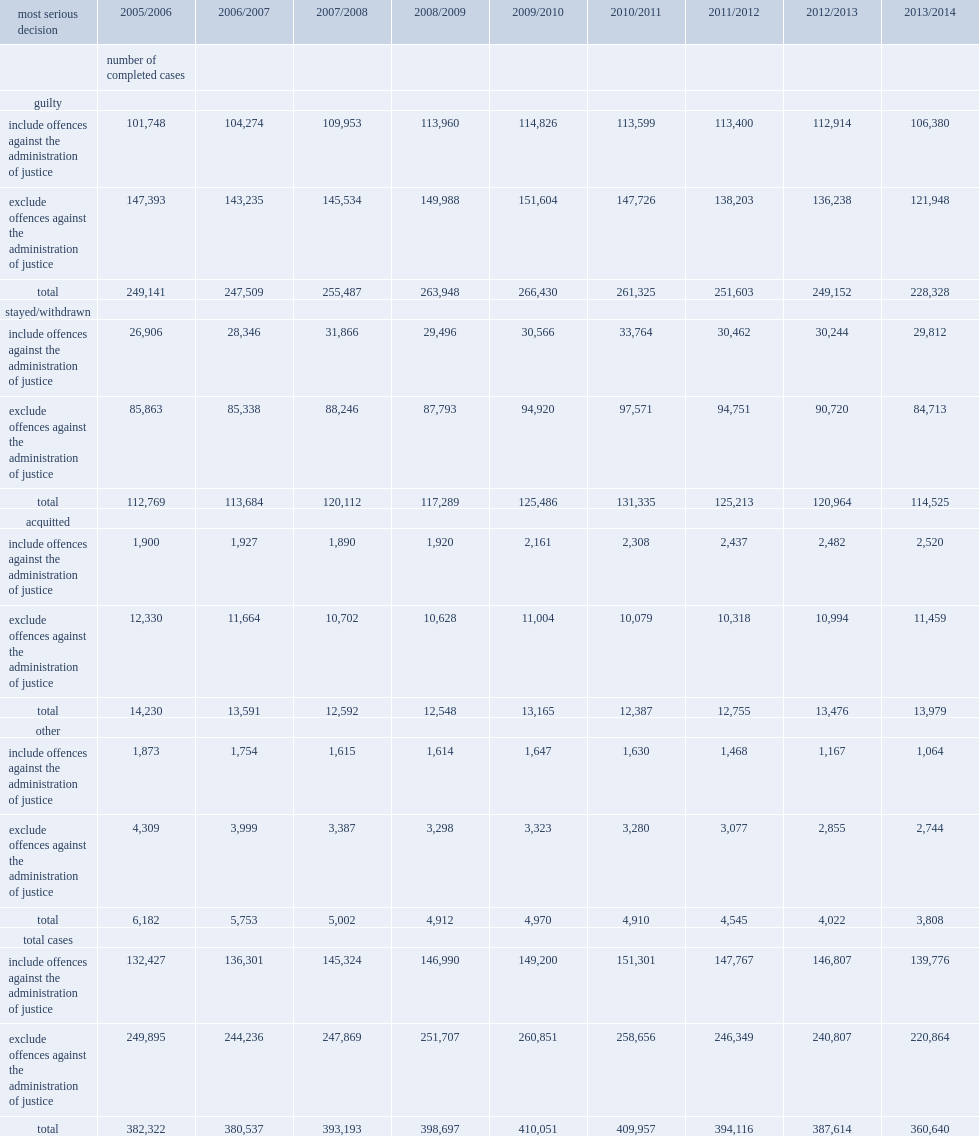What is the percentage of completed court cases that included at least one administration of justice offence resulted in a guilty verdict in 2013/2014? 0.761075. What is the percentage of completed cases that did not include any administration of justice offences where decisions of guilt were handed down in 2013/2014? 0.552141. What is the percentage of completed cases that included offences against the administration of justice in 2013/2014 resulted in charges being stayed or withdrawn? 0.213284. What is the percentage of completed cases where an administration of justice offence was among the charges were acquitted in 2013/2014? 0.018029. What is the percentge of completed adult criminal court cases that did not include any administration of justice charges resulted in acquittals in 2013/2014? 0.051883. 